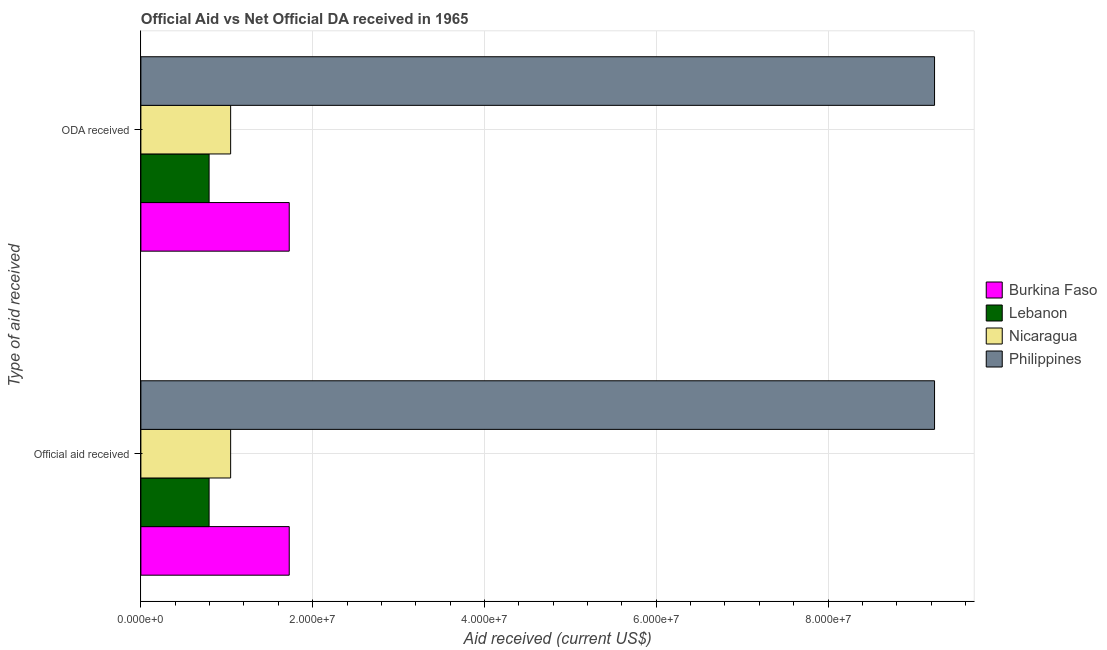How many different coloured bars are there?
Make the answer very short. 4. How many groups of bars are there?
Your answer should be very brief. 2. Are the number of bars per tick equal to the number of legend labels?
Provide a succinct answer. Yes. What is the label of the 1st group of bars from the top?
Your answer should be compact. ODA received. What is the oda received in Burkina Faso?
Keep it short and to the point. 1.73e+07. Across all countries, what is the maximum oda received?
Ensure brevity in your answer.  9.24e+07. Across all countries, what is the minimum official aid received?
Your answer should be very brief. 7.94e+06. In which country was the official aid received minimum?
Ensure brevity in your answer.  Lebanon. What is the total oda received in the graph?
Make the answer very short. 1.28e+08. What is the difference between the official aid received in Burkina Faso and that in Nicaragua?
Give a very brief answer. 6.82e+06. What is the difference between the official aid received in Nicaragua and the oda received in Burkina Faso?
Offer a terse response. -6.82e+06. What is the average oda received per country?
Your response must be concise. 3.20e+07. What is the ratio of the official aid received in Burkina Faso to that in Nicaragua?
Keep it short and to the point. 1.65. Is the oda received in Nicaragua less than that in Lebanon?
Ensure brevity in your answer.  No. What does the 3rd bar from the top in Official aid received represents?
Offer a terse response. Lebanon. What does the 3rd bar from the bottom in ODA received represents?
Ensure brevity in your answer.  Nicaragua. Does the graph contain grids?
Offer a very short reply. Yes. Where does the legend appear in the graph?
Provide a succinct answer. Center right. How many legend labels are there?
Offer a terse response. 4. How are the legend labels stacked?
Your response must be concise. Vertical. What is the title of the graph?
Offer a terse response. Official Aid vs Net Official DA received in 1965 . Does "Luxembourg" appear as one of the legend labels in the graph?
Give a very brief answer. No. What is the label or title of the X-axis?
Your response must be concise. Aid received (current US$). What is the label or title of the Y-axis?
Give a very brief answer. Type of aid received. What is the Aid received (current US$) in Burkina Faso in Official aid received?
Your answer should be compact. 1.73e+07. What is the Aid received (current US$) in Lebanon in Official aid received?
Give a very brief answer. 7.94e+06. What is the Aid received (current US$) of Nicaragua in Official aid received?
Your response must be concise. 1.04e+07. What is the Aid received (current US$) in Philippines in Official aid received?
Provide a succinct answer. 9.24e+07. What is the Aid received (current US$) of Burkina Faso in ODA received?
Your answer should be compact. 1.73e+07. What is the Aid received (current US$) of Lebanon in ODA received?
Offer a terse response. 7.94e+06. What is the Aid received (current US$) in Nicaragua in ODA received?
Keep it short and to the point. 1.04e+07. What is the Aid received (current US$) of Philippines in ODA received?
Your response must be concise. 9.24e+07. Across all Type of aid received, what is the maximum Aid received (current US$) in Burkina Faso?
Offer a terse response. 1.73e+07. Across all Type of aid received, what is the maximum Aid received (current US$) in Lebanon?
Provide a succinct answer. 7.94e+06. Across all Type of aid received, what is the maximum Aid received (current US$) in Nicaragua?
Offer a terse response. 1.04e+07. Across all Type of aid received, what is the maximum Aid received (current US$) in Philippines?
Ensure brevity in your answer.  9.24e+07. Across all Type of aid received, what is the minimum Aid received (current US$) of Burkina Faso?
Your answer should be compact. 1.73e+07. Across all Type of aid received, what is the minimum Aid received (current US$) of Lebanon?
Provide a succinct answer. 7.94e+06. Across all Type of aid received, what is the minimum Aid received (current US$) of Nicaragua?
Make the answer very short. 1.04e+07. Across all Type of aid received, what is the minimum Aid received (current US$) of Philippines?
Offer a very short reply. 9.24e+07. What is the total Aid received (current US$) of Burkina Faso in the graph?
Provide a succinct answer. 3.45e+07. What is the total Aid received (current US$) of Lebanon in the graph?
Offer a very short reply. 1.59e+07. What is the total Aid received (current US$) of Nicaragua in the graph?
Ensure brevity in your answer.  2.09e+07. What is the total Aid received (current US$) of Philippines in the graph?
Keep it short and to the point. 1.85e+08. What is the difference between the Aid received (current US$) in Burkina Faso in Official aid received and that in ODA received?
Your answer should be very brief. 0. What is the difference between the Aid received (current US$) in Philippines in Official aid received and that in ODA received?
Offer a very short reply. 0. What is the difference between the Aid received (current US$) in Burkina Faso in Official aid received and the Aid received (current US$) in Lebanon in ODA received?
Offer a very short reply. 9.33e+06. What is the difference between the Aid received (current US$) in Burkina Faso in Official aid received and the Aid received (current US$) in Nicaragua in ODA received?
Offer a terse response. 6.82e+06. What is the difference between the Aid received (current US$) of Burkina Faso in Official aid received and the Aid received (current US$) of Philippines in ODA received?
Offer a terse response. -7.51e+07. What is the difference between the Aid received (current US$) in Lebanon in Official aid received and the Aid received (current US$) in Nicaragua in ODA received?
Your response must be concise. -2.51e+06. What is the difference between the Aid received (current US$) of Lebanon in Official aid received and the Aid received (current US$) of Philippines in ODA received?
Make the answer very short. -8.45e+07. What is the difference between the Aid received (current US$) of Nicaragua in Official aid received and the Aid received (current US$) of Philippines in ODA received?
Offer a very short reply. -8.20e+07. What is the average Aid received (current US$) of Burkina Faso per Type of aid received?
Your response must be concise. 1.73e+07. What is the average Aid received (current US$) of Lebanon per Type of aid received?
Your answer should be very brief. 7.94e+06. What is the average Aid received (current US$) of Nicaragua per Type of aid received?
Your answer should be very brief. 1.04e+07. What is the average Aid received (current US$) of Philippines per Type of aid received?
Your answer should be compact. 9.24e+07. What is the difference between the Aid received (current US$) of Burkina Faso and Aid received (current US$) of Lebanon in Official aid received?
Provide a short and direct response. 9.33e+06. What is the difference between the Aid received (current US$) in Burkina Faso and Aid received (current US$) in Nicaragua in Official aid received?
Keep it short and to the point. 6.82e+06. What is the difference between the Aid received (current US$) of Burkina Faso and Aid received (current US$) of Philippines in Official aid received?
Provide a succinct answer. -7.51e+07. What is the difference between the Aid received (current US$) of Lebanon and Aid received (current US$) of Nicaragua in Official aid received?
Offer a terse response. -2.51e+06. What is the difference between the Aid received (current US$) in Lebanon and Aid received (current US$) in Philippines in Official aid received?
Offer a terse response. -8.45e+07. What is the difference between the Aid received (current US$) of Nicaragua and Aid received (current US$) of Philippines in Official aid received?
Ensure brevity in your answer.  -8.20e+07. What is the difference between the Aid received (current US$) in Burkina Faso and Aid received (current US$) in Lebanon in ODA received?
Your answer should be very brief. 9.33e+06. What is the difference between the Aid received (current US$) of Burkina Faso and Aid received (current US$) of Nicaragua in ODA received?
Your answer should be compact. 6.82e+06. What is the difference between the Aid received (current US$) of Burkina Faso and Aid received (current US$) of Philippines in ODA received?
Give a very brief answer. -7.51e+07. What is the difference between the Aid received (current US$) of Lebanon and Aid received (current US$) of Nicaragua in ODA received?
Provide a succinct answer. -2.51e+06. What is the difference between the Aid received (current US$) of Lebanon and Aid received (current US$) of Philippines in ODA received?
Your answer should be very brief. -8.45e+07. What is the difference between the Aid received (current US$) in Nicaragua and Aid received (current US$) in Philippines in ODA received?
Provide a short and direct response. -8.20e+07. What is the ratio of the Aid received (current US$) in Burkina Faso in Official aid received to that in ODA received?
Your response must be concise. 1. What is the ratio of the Aid received (current US$) of Lebanon in Official aid received to that in ODA received?
Your response must be concise. 1. What is the ratio of the Aid received (current US$) of Philippines in Official aid received to that in ODA received?
Offer a terse response. 1. What is the difference between the highest and the second highest Aid received (current US$) of Lebanon?
Offer a very short reply. 0. What is the difference between the highest and the second highest Aid received (current US$) of Philippines?
Offer a very short reply. 0. What is the difference between the highest and the lowest Aid received (current US$) in Burkina Faso?
Provide a succinct answer. 0. What is the difference between the highest and the lowest Aid received (current US$) of Nicaragua?
Keep it short and to the point. 0. What is the difference between the highest and the lowest Aid received (current US$) in Philippines?
Your answer should be very brief. 0. 